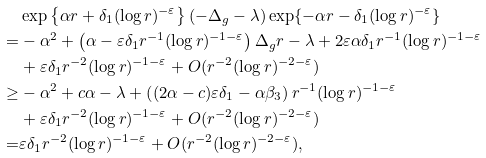Convert formula to latex. <formula><loc_0><loc_0><loc_500><loc_500>& \exp \left \{ \alpha r + \delta _ { 1 } ( \log r ) ^ { - \varepsilon } \right \} ( - \Delta _ { g } - \lambda ) \exp \{ - \alpha r - \delta _ { 1 } ( \log r ) ^ { - \varepsilon } \} \\ = & - \alpha ^ { 2 } + \left ( \alpha - \varepsilon \delta _ { 1 } r ^ { - 1 } ( \log r ) ^ { - 1 - \varepsilon } \right ) \Delta _ { g } r - \lambda + 2 \varepsilon \alpha \delta _ { 1 } r ^ { - 1 } ( \log r ) ^ { - 1 - \varepsilon } \\ & + \varepsilon \delta _ { 1 } r ^ { - 2 } ( \log r ) ^ { - 1 - \varepsilon } + O ( r ^ { - 2 } ( \log r ) ^ { - 2 - \varepsilon } ) \\ \geq & - \alpha ^ { 2 } + c \alpha - \lambda + \left ( ( 2 \alpha - c ) \varepsilon \delta _ { 1 } - \alpha \beta _ { 3 } \right ) r ^ { - 1 } ( \log r ) ^ { - 1 - \varepsilon } \\ & + \varepsilon \delta _ { 1 } r ^ { - 2 } ( \log r ) ^ { - 1 - \varepsilon } + O ( r ^ { - 2 } ( \log r ) ^ { - 2 - \varepsilon } ) \\ = & \varepsilon \delta _ { 1 } r ^ { - 2 } ( \log r ) ^ { - 1 - \varepsilon } + O ( r ^ { - 2 } ( \log r ) ^ { - 2 - \varepsilon } ) ,</formula> 